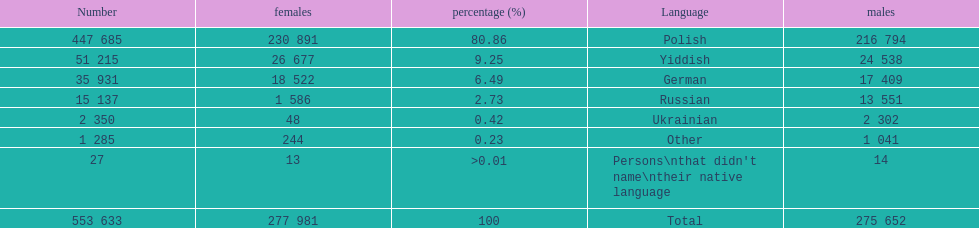Which language did only .42% of people in the imperial census of 1897 speak in the p&#322;ock governorate? Ukrainian. 